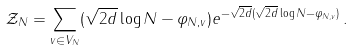<formula> <loc_0><loc_0><loc_500><loc_500>\mathcal { Z } _ { N } = \sum _ { v \in V _ { N } } ( \sqrt { 2 d } \log N - \varphi _ { N , v } ) e ^ { - \sqrt { 2 d } ( \sqrt { 2 d } \log N - \varphi _ { N , v } ) } \, .</formula> 